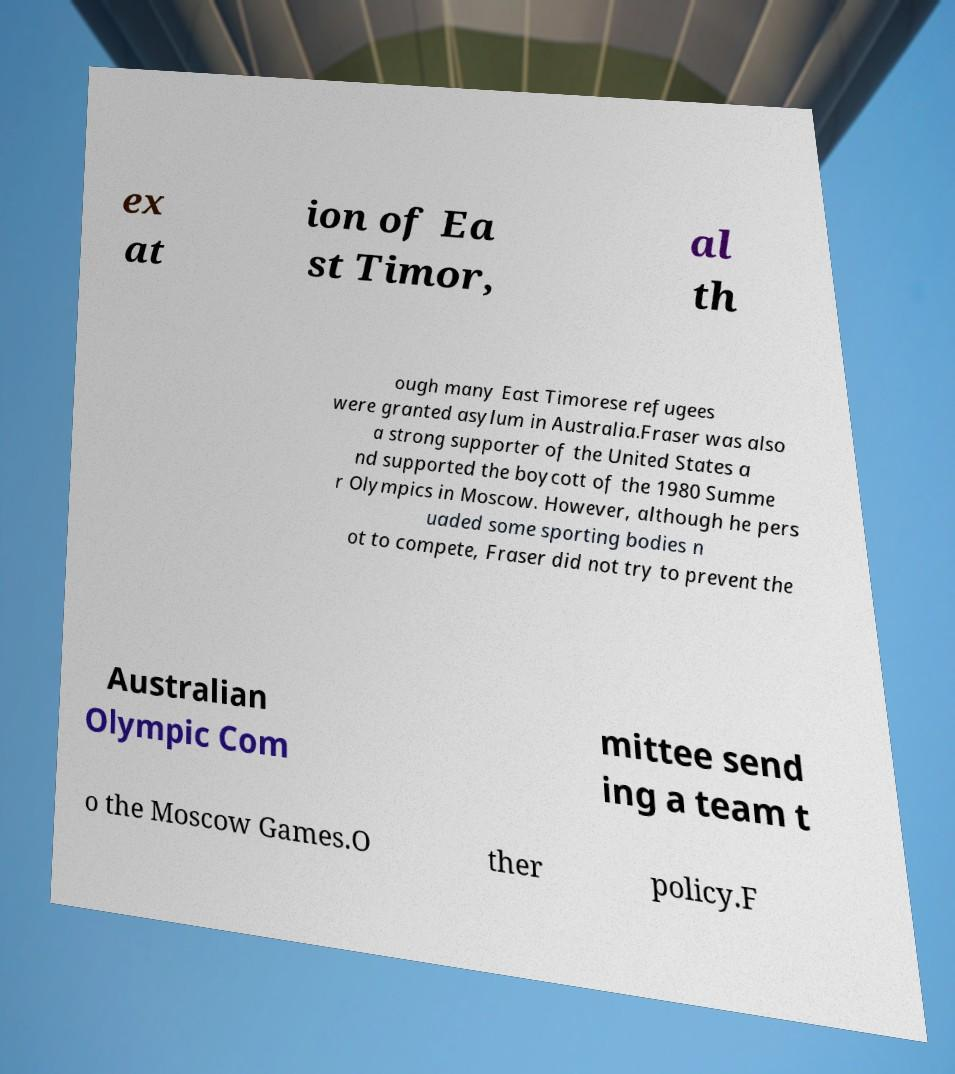What messages or text are displayed in this image? I need them in a readable, typed format. ex at ion of Ea st Timor, al th ough many East Timorese refugees were granted asylum in Australia.Fraser was also a strong supporter of the United States a nd supported the boycott of the 1980 Summe r Olympics in Moscow. However, although he pers uaded some sporting bodies n ot to compete, Fraser did not try to prevent the Australian Olympic Com mittee send ing a team t o the Moscow Games.O ther policy.F 